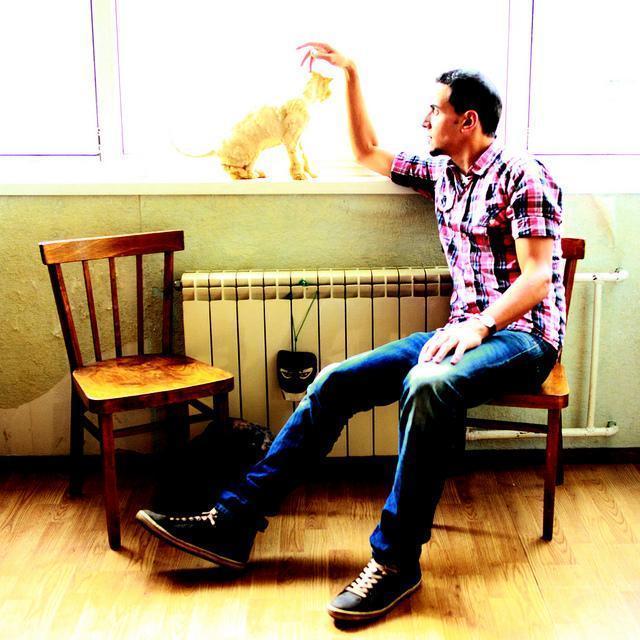How many chairs that are empty?
Give a very brief answer. 1. How many chairs can be seen?
Give a very brief answer. 2. 